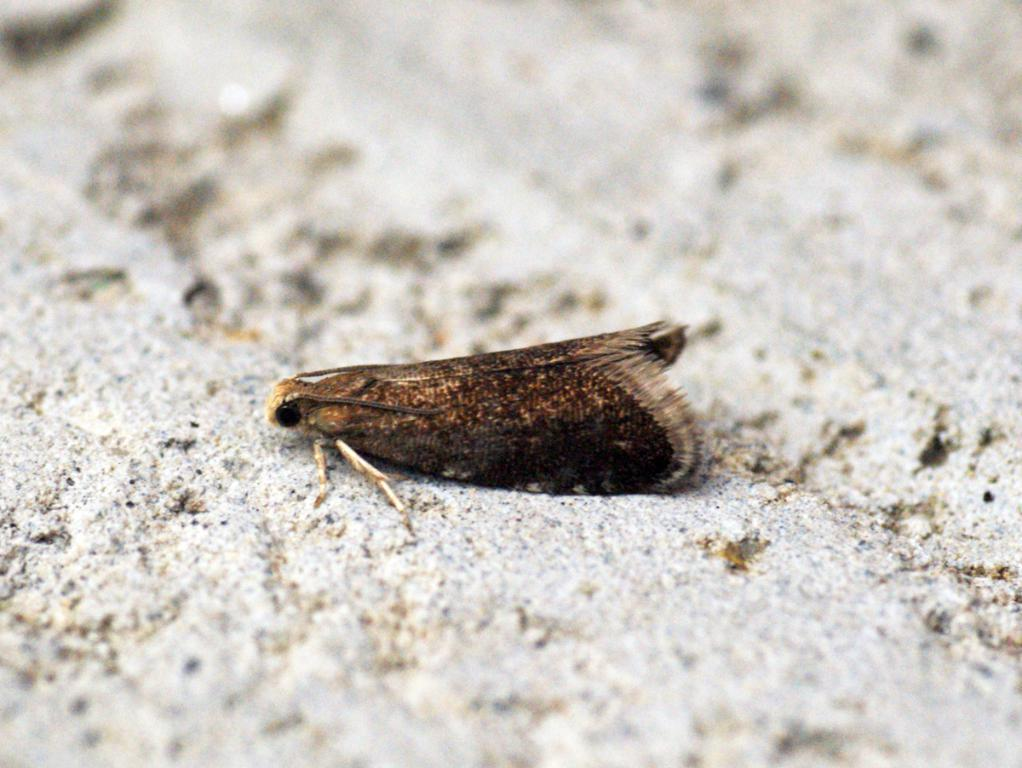What type of creature is in the picture? There is an insect in the picture. What body parts does the insect have? The insect has legs, antennae, and wings. What is the color of the insect? The insect is brown in color. What type of dirt can be seen on the insect's vest in the image? There is no dirt or vest present on the insect in the image. What type of amusement can be seen in the background of the image? There is no amusement or background visible in the image, as it only features the insect. 